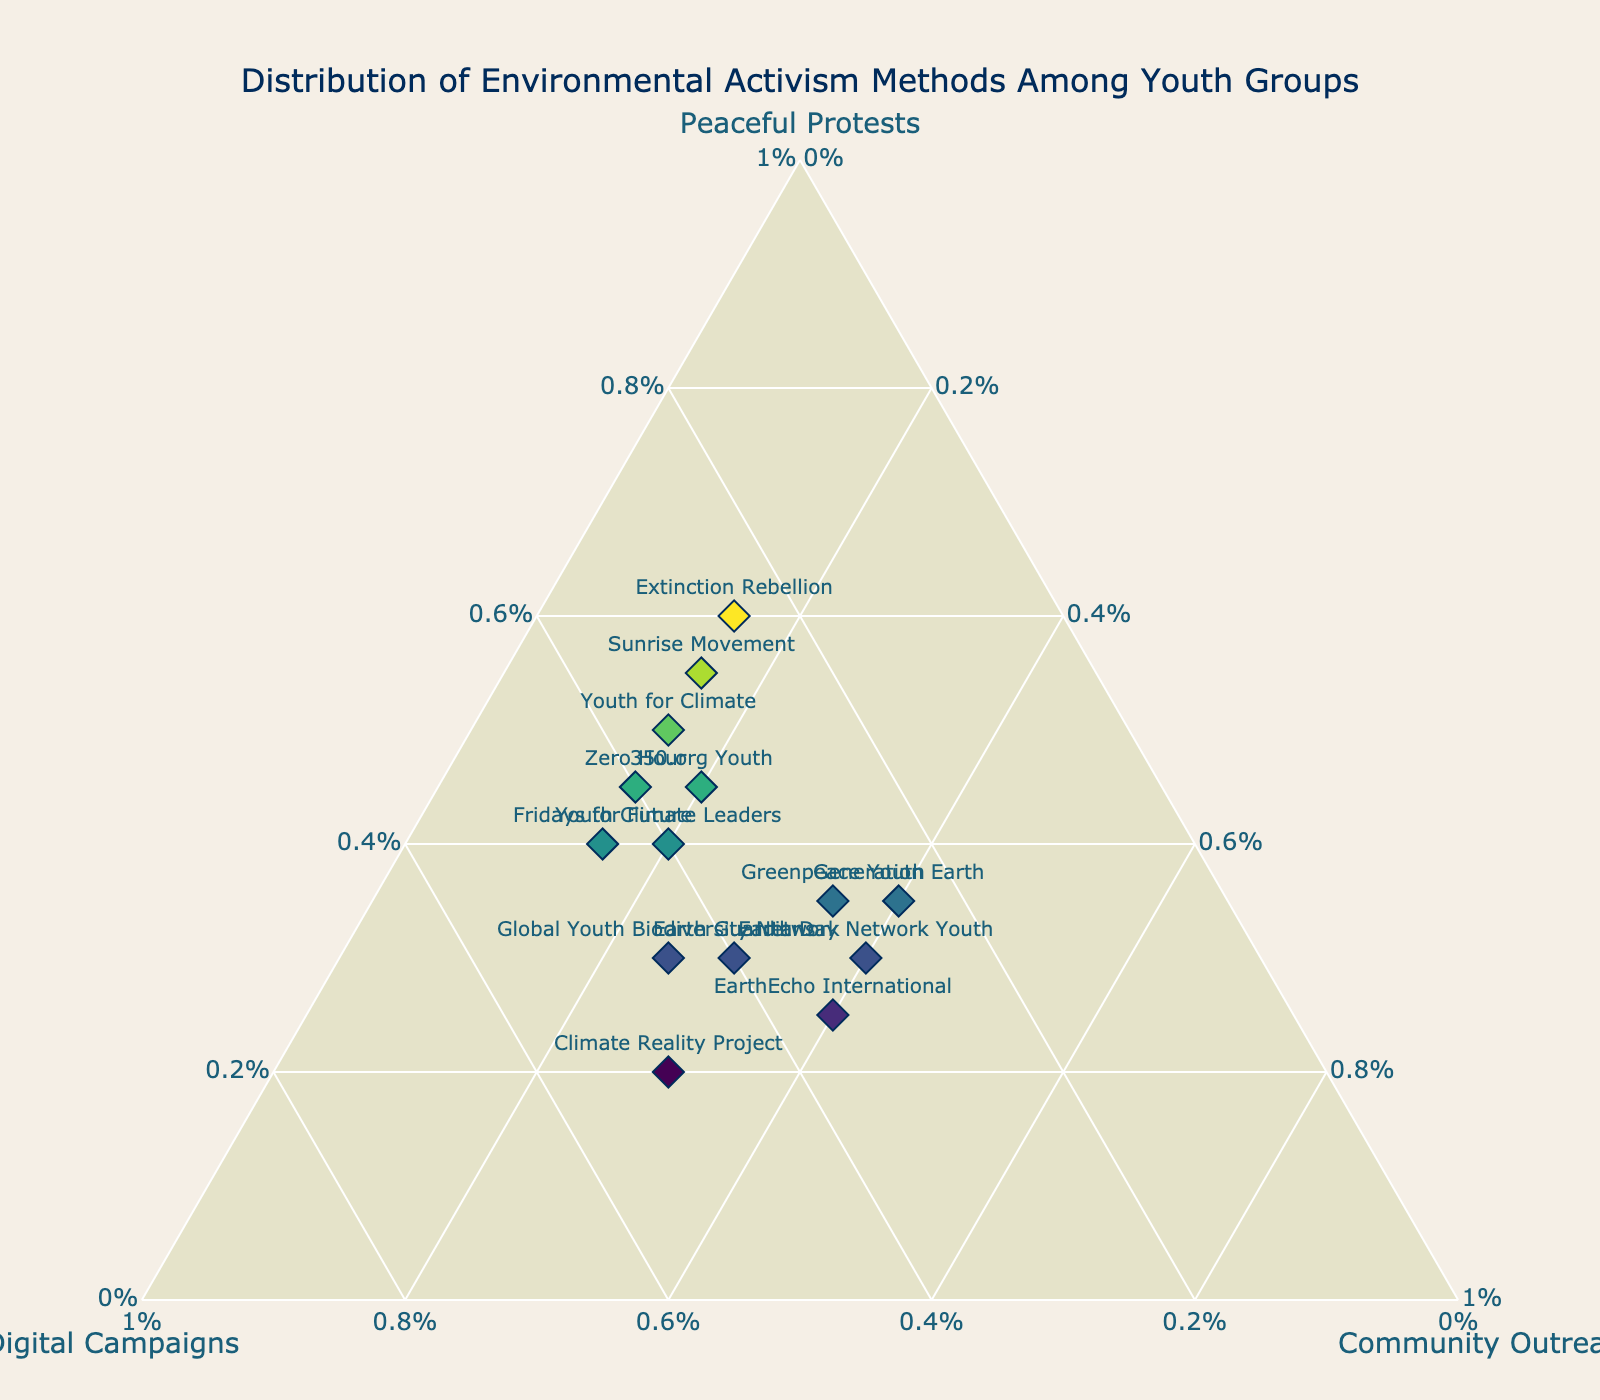What is the title of the plot? The title of the plot is displayed prominently and can be read directly from the figure. It’s usually at the top.
Answer: Distribution of Environmental Activism Methods Among Youth Groups How many groups are included in the figure? To find out how many groups are included, count the number of labels corresponding to the groups marked on the plot.
Answer: 14 Which group focuses the most on Digital Campaigns? Look at the 'Digital Campaigns' axis for the group that has the highest value. The value is shown alongside the group's name in the hover information.
Answer: Climate Reality Project What are the three activism methods represented in this ternary plot? Check the axis titles to determine the three methods represented.
Answer: Peaceful Protests, Digital Campaigns, Community Outreach Which group has an equal percentage of Digital Campaigns and Community Outreach? Look for a group where the digital campaigns and community outreach percentages are the same. This will be indicated in the text hover or marker position relative to both axes.
Answer: Earth Guardians Which group emphasizes Peaceful Protests more than any other method? Identify the group with the highest percentage on the Peaceful Protests axis relative to the other two methods.
Answer: Extinction Rebellion Compare Sunrise Movement and Youth for Climate. Which one has a higher percentage of Peaceful Protests? Find the percentages of Peaceful Protests for both groups and compare them. Sunrise Movement has 55%, and Youth for Climate has 50%.
Answer: Sunrise Movement What is the difference in the percentage of Community Outreach between EarthEcho International and Greenpeace Youth? Subtract the smaller percentage from the larger one. Greenpeace Youth has 35%, and EarthEcho International has 40%. The difference is 40% - 35% = 5%.
Answer: 5% What is the sum of percentages for Digital Campaigns and Community Outreach for Generation Earth? Add the percentages for Digital Campaigns and Community Outreach for Generation Earth. Digital Campaigns: 25%, Community Outreach: 40%. Sum = 25% + 40% = 65%.
Answer: 65% How many groups have a higher percentage in Community Outreach than Digital Campaigns? Examine the plot or hover text to determine each group’s percentages in Community Outreach and Digital Campaigns and count how many groups have a higher percentage for Community Outreach. These groups are EarthEcho International, Earth Day Network Youth, and Generation Earth.
Answer: 3 